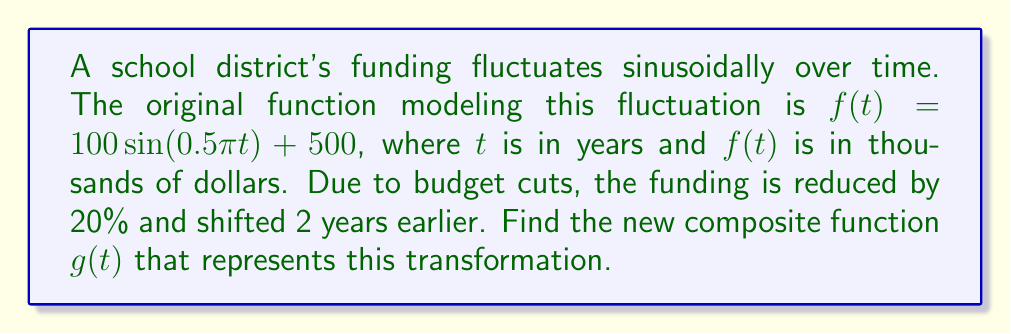Give your solution to this math problem. 1) First, we need to identify the transformations:
   - 20% reduction: multiply the function by 0.8
   - Shift 2 years earlier: replace $t$ with $(t+2)$

2) Let's apply these transformations step by step:

   Original function: $f(t) = 100\sin(0.5\pi t) + 500$

   Step 1: 20% reduction
   $0.8[100\sin(0.5\pi t) + 500]$
   $= 80\sin(0.5\pi t) + 400$

   Step 2: Shift 2 years earlier
   Replace $t$ with $(t+2)$:
   $g(t) = 80\sin(0.5\pi (t+2)) + 400$

3) Simplify the argument of sine:
   $g(t) = 80\sin(0.5\pi t + \pi) + 400$

4) Recall that $\sin(x + \pi) = -\sin(x)$, so we can further simplify:
   $g(t) = -80\sin(0.5\pi t) + 400$

Therefore, the new composite function is $g(t) = -80\sin(0.5\pi t) + 400$.
Answer: $g(t) = -80\sin(0.5\pi t) + 400$ 